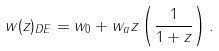Convert formula to latex. <formula><loc_0><loc_0><loc_500><loc_500>w ( z ) _ { D E } = w _ { 0 } + w _ { a } z \left ( \frac { 1 } { 1 + z } \right ) .</formula> 